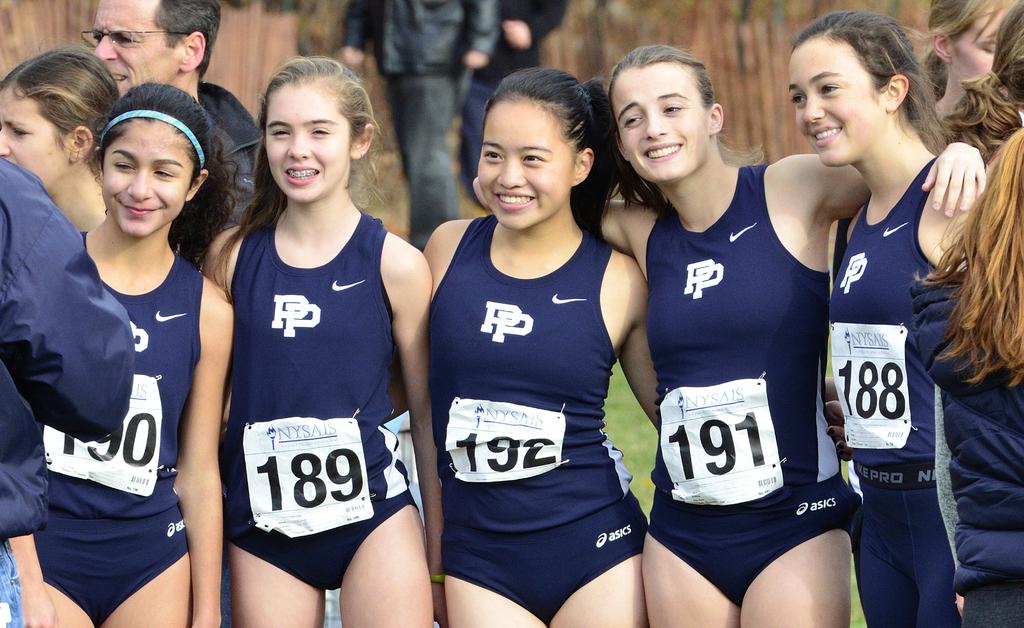What are the letters on the front of the girl's uniforms?
Your answer should be very brief. Pp. What is the number of the girl on the right?
Provide a short and direct response. 188. 